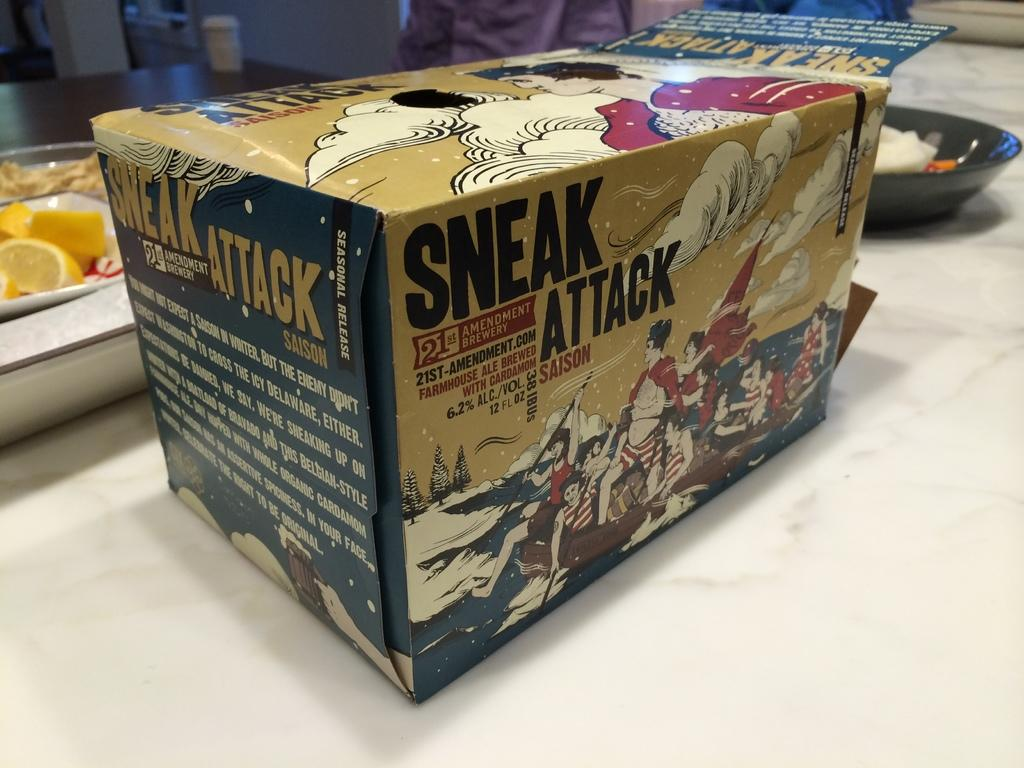<image>
Render a clear and concise summary of the photo. a box with the words sneak attack on it on a table 